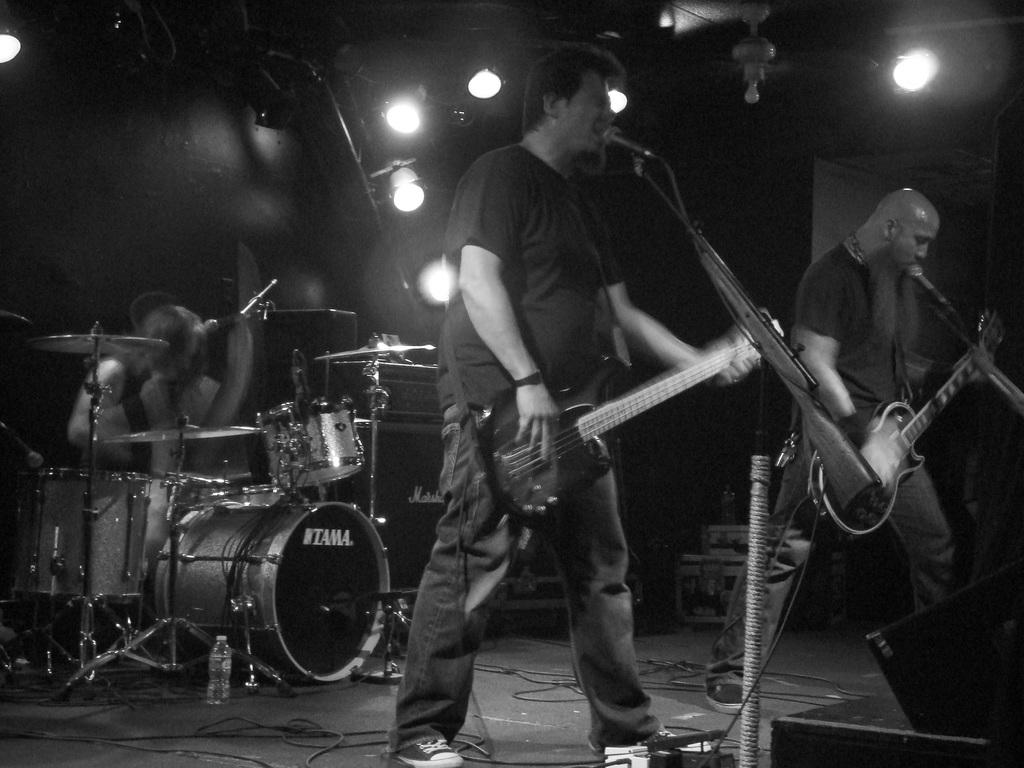What are the people in the image doing? The people in the image are singing. What are the people holding while singing? The people are holding microphones and guitars. What other musical instrument can be seen in the image? There are musical drums on the left side of the image. How many beans are visible on the guitars in the image? There are no beans visible on the guitars in the image. What type of vein is present in the microphones in the image? There are no veins present in the microphones in the image. 